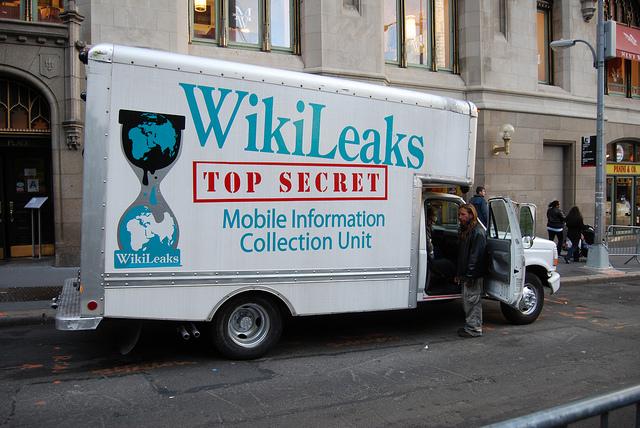What is this vehicle for?
Answer briefly. Moving. Can we see through this vehicle?
Answer briefly. No. What kind of activity is this truck for?
Keep it brief. Collection. What time of day is it?
Write a very short answer. Afternoon. What color is the truck?
Keep it brief. White. Is the WikiLeaks truck a semi?
Short answer required. No. Is WikiLeaks a secret?
Write a very short answer. No. 